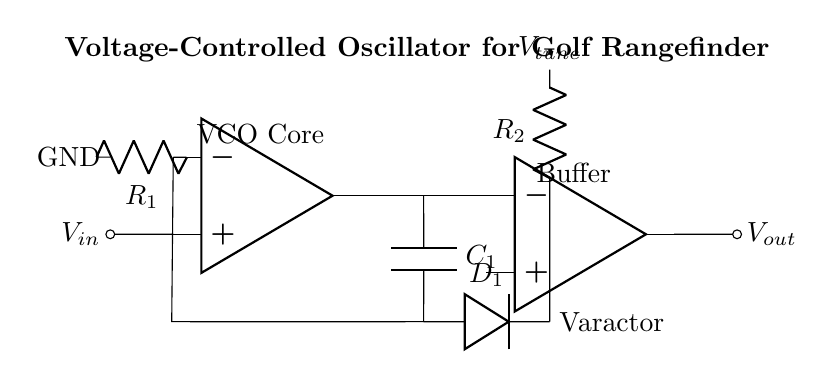What is the main function of the op-amp in this circuit? The op-amp serves as the core of the voltage-controlled oscillator, amplifying the input signal to produce oscillations.
Answer: Oscillator core What type of capacitor is used in this circuit? The circuit uses a capacitor labeled C1 for feedback; this forms part of the oscillation process.
Answer: Capacitor What is the role of the varactor diode in the circuit? The varactor diode, labeled D1, is used for voltage tuning, adjusting the capacitance and therefore the oscillation frequency.
Answer: Voltage tuning How many resistors are present in the circuit? There are two resistors, R1 and R2, that help set the gain and control the frequency of oscillation in the feedback loop.
Answer: Two resistors What happens to the output frequency when V_tune is increased? Increasing V_tune changes the capacitance of D1, which generally lowers the output frequency since the oscillator frequency depends inversely on capacitance.
Answer: Output frequency decreases What is the output voltage labeled on the circuit? The output voltage, V_out, illustrates the signal output from the buffer used to isolate the op-amp output for further processing or measurement.
Answer: V_out 